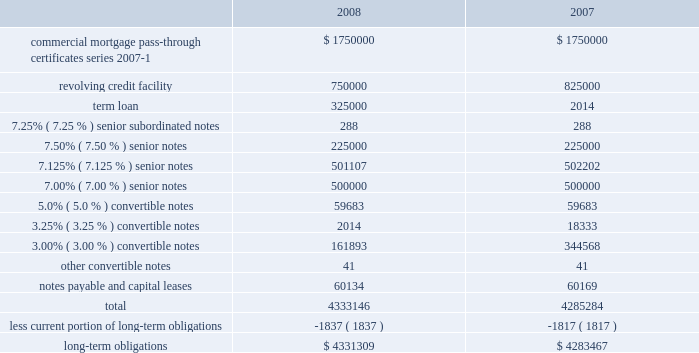American tower corporation and subsidiaries notes to consolidated financial statements 2014 ( continued ) 6 .
Long-term obligations outstanding amounts under the company 2019s long-term financing arrangements consist of the following as of december 31 , ( in thousands ) : .
Commercial mortgage pass-through certificates , series 2007-1 2014during the year ended december 31 , 2007 , the company completed a securitization transaction ( the securitization ) involving assets related to 5295 broadcast and wireless communications towers ( the secured towers ) owned by two special purpose subsidiaries of the company , through a private offering of $ 1.75 billion of commercial mortgage pass-through certificates , series 2007-1 ( the certificates ) .
The certificates were issued by american tower trust i ( the trust ) , a trust established by american tower depositor sub , llc ( the depositor ) , an indirect wholly owned special purpose subsidiary of the company .
The assets of the trust consist of a recourse loan ( the loan ) initially made by the depositor to american tower asset sub , llc and american tower asset sub ii , llc ( the borrowers ) , pursuant to a loan and security agreement among the foregoing parties dated as of may 4 , 2007 ( the loan agreement ) .
The borrowers are special purpose entities formed solely for the purpose of holding the secured towers subject to the securitization .
The certificates were issued in seven separate classes , comprised of class a-fx , class a-fl , class b , class c , class d , class e and class f .
Each of the certificates in classes b , c , d , e and f are subordinated in right of payment to any other class of certificates which has an earlier alphabetical designation .
The certificates were issued with terms identical to the loan except for the class a-fl certificates , which bear interest at a floating rate while the related component of the loan bears interest at a fixed rate , as described below .
The various classes of certificates were issued with a weighted average interest rate of approximately 5.61% ( 5.61 % ) .
The certificates have an expected life of approximately seven years with a final repayment date in april 2037 .
The company used the net proceeds from the securitization to repay all amounts outstanding under the spectrasite credit facilities , including approximately $ 765.0 million in principal , plus accrued interest thereon and other costs and expenses related thereto , as well as to repay approximately $ 250.0 million drawn under the revolving loan component of the credit facilities at the american tower operating company level .
An additional $ 349.5 million of the proceeds was used to fund the company 2019s tender offer and consent solicitation for the ati .
What was the change in thousands in long-term obligations from 2007 to 2008? 
Computations: (4331309 - 4283467)
Answer: 47842.0. 